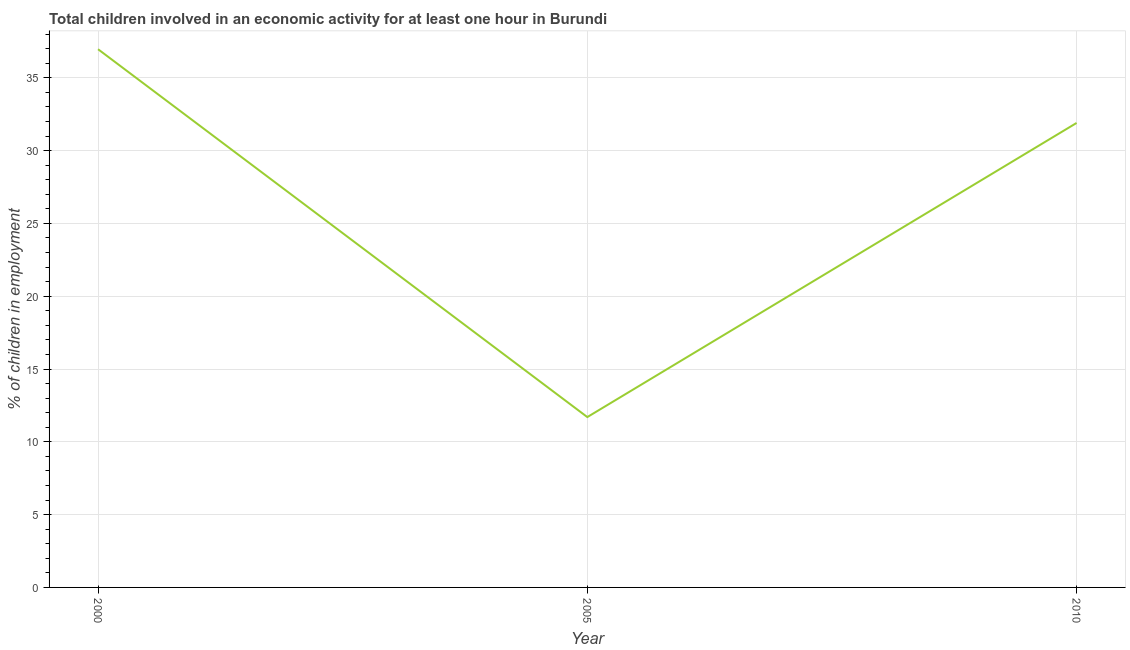Across all years, what is the maximum percentage of children in employment?
Offer a terse response. 36.96. Across all years, what is the minimum percentage of children in employment?
Your response must be concise. 11.7. What is the sum of the percentage of children in employment?
Offer a very short reply. 80.56. What is the difference between the percentage of children in employment in 2000 and 2010?
Provide a short and direct response. 5.06. What is the average percentage of children in employment per year?
Offer a very short reply. 26.85. What is the median percentage of children in employment?
Offer a terse response. 31.9. In how many years, is the percentage of children in employment greater than 34 %?
Your answer should be compact. 1. What is the ratio of the percentage of children in employment in 2005 to that in 2010?
Make the answer very short. 0.37. Is the percentage of children in employment in 2000 less than that in 2005?
Provide a succinct answer. No. Is the difference between the percentage of children in employment in 2005 and 2010 greater than the difference between any two years?
Your answer should be compact. No. What is the difference between the highest and the second highest percentage of children in employment?
Offer a terse response. 5.06. Is the sum of the percentage of children in employment in 2000 and 2005 greater than the maximum percentage of children in employment across all years?
Provide a short and direct response. Yes. What is the difference between the highest and the lowest percentage of children in employment?
Offer a terse response. 25.26. How many years are there in the graph?
Your answer should be very brief. 3. What is the difference between two consecutive major ticks on the Y-axis?
Provide a short and direct response. 5. Does the graph contain any zero values?
Offer a very short reply. No. Does the graph contain grids?
Offer a terse response. Yes. What is the title of the graph?
Your answer should be very brief. Total children involved in an economic activity for at least one hour in Burundi. What is the label or title of the X-axis?
Keep it short and to the point. Year. What is the label or title of the Y-axis?
Ensure brevity in your answer.  % of children in employment. What is the % of children in employment of 2000?
Your answer should be very brief. 36.96. What is the % of children in employment in 2005?
Provide a succinct answer. 11.7. What is the % of children in employment in 2010?
Provide a succinct answer. 31.9. What is the difference between the % of children in employment in 2000 and 2005?
Provide a short and direct response. 25.26. What is the difference between the % of children in employment in 2000 and 2010?
Provide a succinct answer. 5.06. What is the difference between the % of children in employment in 2005 and 2010?
Give a very brief answer. -20.2. What is the ratio of the % of children in employment in 2000 to that in 2005?
Your answer should be very brief. 3.16. What is the ratio of the % of children in employment in 2000 to that in 2010?
Make the answer very short. 1.16. What is the ratio of the % of children in employment in 2005 to that in 2010?
Provide a succinct answer. 0.37. 